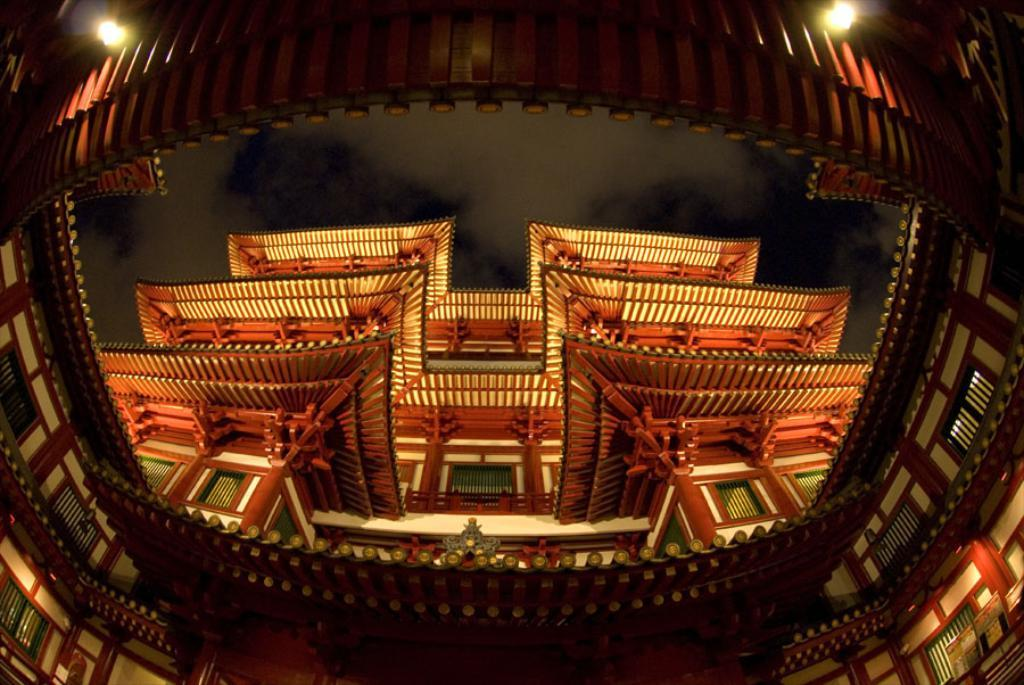What type of structures can be seen in the image? There are buildings in the image. Can you describe any other elements in the image besides the buildings? Yes, there are lights visible in the image. What type of linen is used to cover the buildings in the image? There is no linen present in the image, and the buildings are not covered by any fabric. 